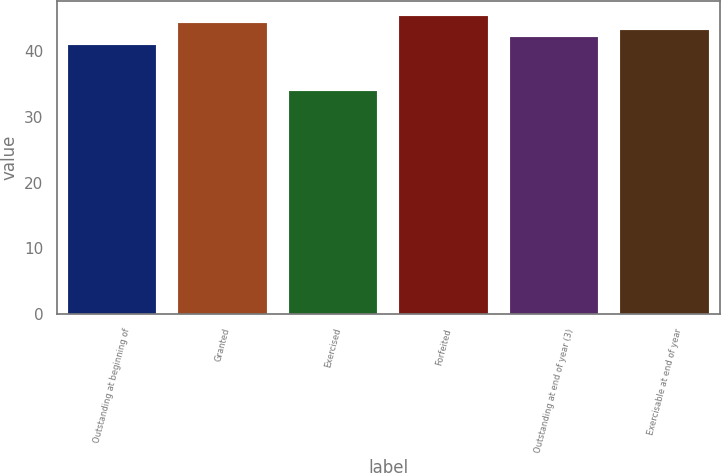Convert chart to OTSL. <chart><loc_0><loc_0><loc_500><loc_500><bar_chart><fcel>Outstanding at beginning of<fcel>Granted<fcel>Exercised<fcel>Forfeited<fcel>Outstanding at end of year (3)<fcel>Exercisable at end of year<nl><fcel>41<fcel>44.3<fcel>34<fcel>45.4<fcel>42.1<fcel>43.2<nl></chart> 